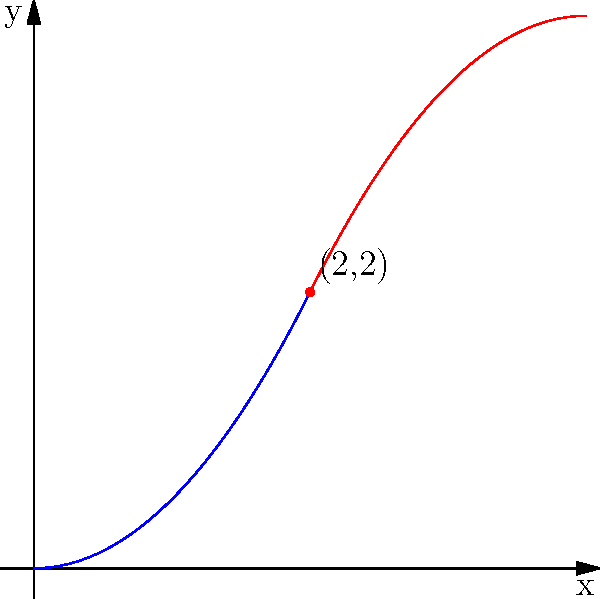In designing a smooth transition between a curved roof and a straight wall for a miniature model, you decide to use a piecewise polynomial function. The function $f(x)$ is defined as:

$$f(x) = \begin{cases} 
0.5x^2 & \text{for } 0 \leq x < 2 \\
-0.5(x-4)^2 + 4 & \text{for } 2 \leq x \leq 4
\end{cases}$$

To ensure a smooth transition, what condition must be satisfied at the point where the two functions meet (i.e., at $x=2$)? To ensure a smooth transition between the two polynomial functions, we need to check for continuity and differentiability at the point where they meet (x=2).

Step 1: Check for continuity
- For continuity, the function values should be equal at x=2.
- For $f_1(x) = 0.5x^2$ at x=2: $f_1(2) = 0.5(2)^2 = 2$
- For $f_2(x) = -0.5(x-4)^2 + 4$ at x=2: $f_2(2) = -0.5(2-4)^2 + 4 = -0.5(-2)^2 + 4 = 2$
- The function values are equal, so it's continuous.

Step 2: Check for differentiability
- For differentiability, the derivatives should be equal at x=2.
- Derivative of $f_1(x)$: $f_1'(x) = x$
- At x=2: $f_1'(2) = 2$
- Derivative of $f_2(x)$: $f_2'(x) = -(x-4)$
- At x=2: $f_2'(2) = -(2-4) = 2$
- The derivatives are equal, so it's differentiable.

Since both continuity and differentiability conditions are satisfied at x=2, the transition is smooth.

The condition that must be satisfied for a smooth transition is that both the function values and their first derivatives must be equal at the point where the two functions meet (x=2).
Answer: Continuity and equal first derivatives at x=2 